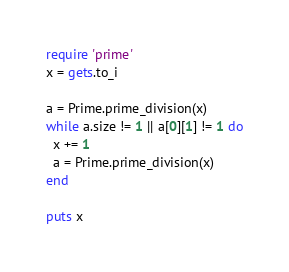Convert code to text. <code><loc_0><loc_0><loc_500><loc_500><_Ruby_>require 'prime'
x = gets.to_i
 
a = Prime.prime_division(x)
while a.size != 1 || a[0][1] != 1 do
  x += 1
  a = Prime.prime_division(x)
end
 
puts x</code> 